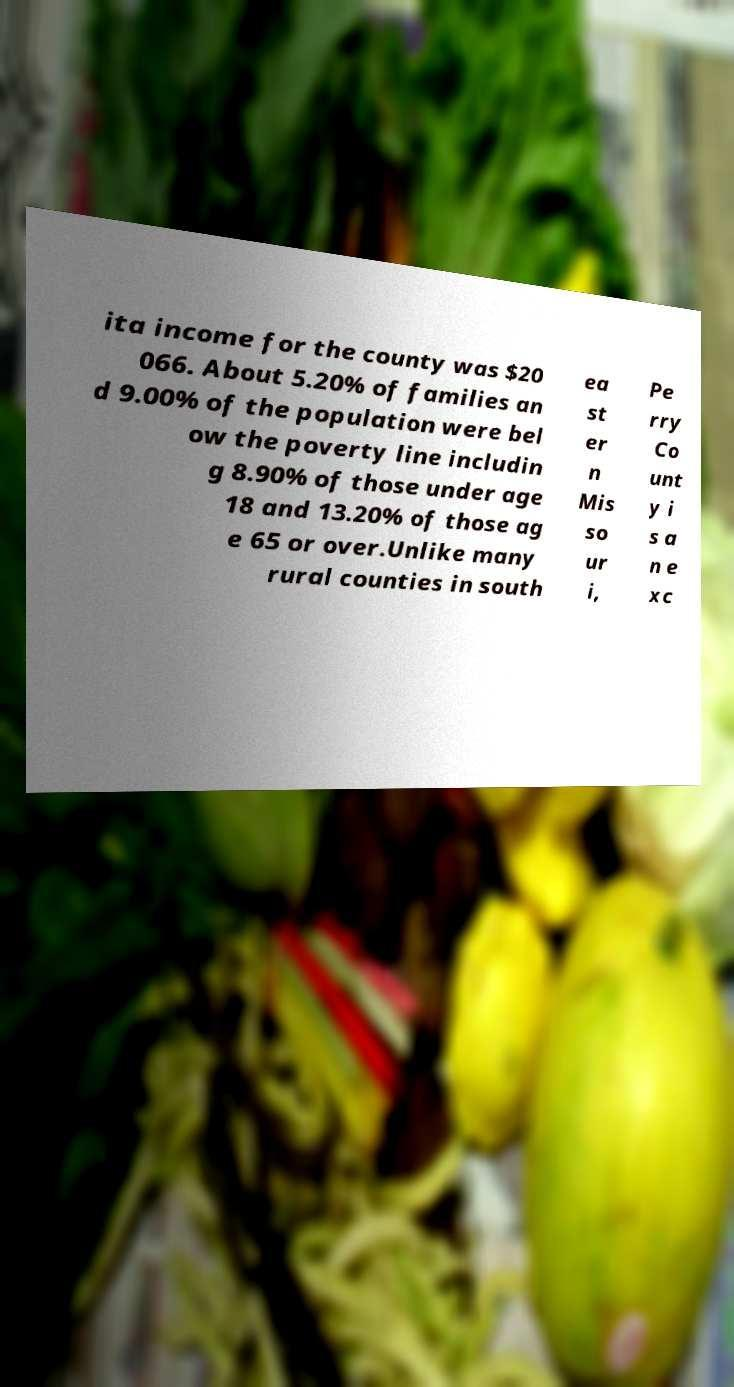Could you extract and type out the text from this image? ita income for the county was $20 066. About 5.20% of families an d 9.00% of the population were bel ow the poverty line includin g 8.90% of those under age 18 and 13.20% of those ag e 65 or over.Unlike many rural counties in south ea st er n Mis so ur i, Pe rry Co unt y i s a n e xc 